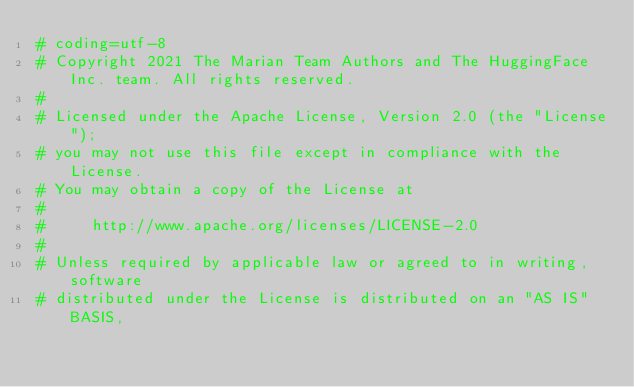Convert code to text. <code><loc_0><loc_0><loc_500><loc_500><_Python_># coding=utf-8
# Copyright 2021 The Marian Team Authors and The HuggingFace Inc. team. All rights reserved.
#
# Licensed under the Apache License, Version 2.0 (the "License");
# you may not use this file except in compliance with the License.
# You may obtain a copy of the License at
#
#     http://www.apache.org/licenses/LICENSE-2.0
#
# Unless required by applicable law or agreed to in writing, software
# distributed under the License is distributed on an "AS IS" BASIS,</code> 